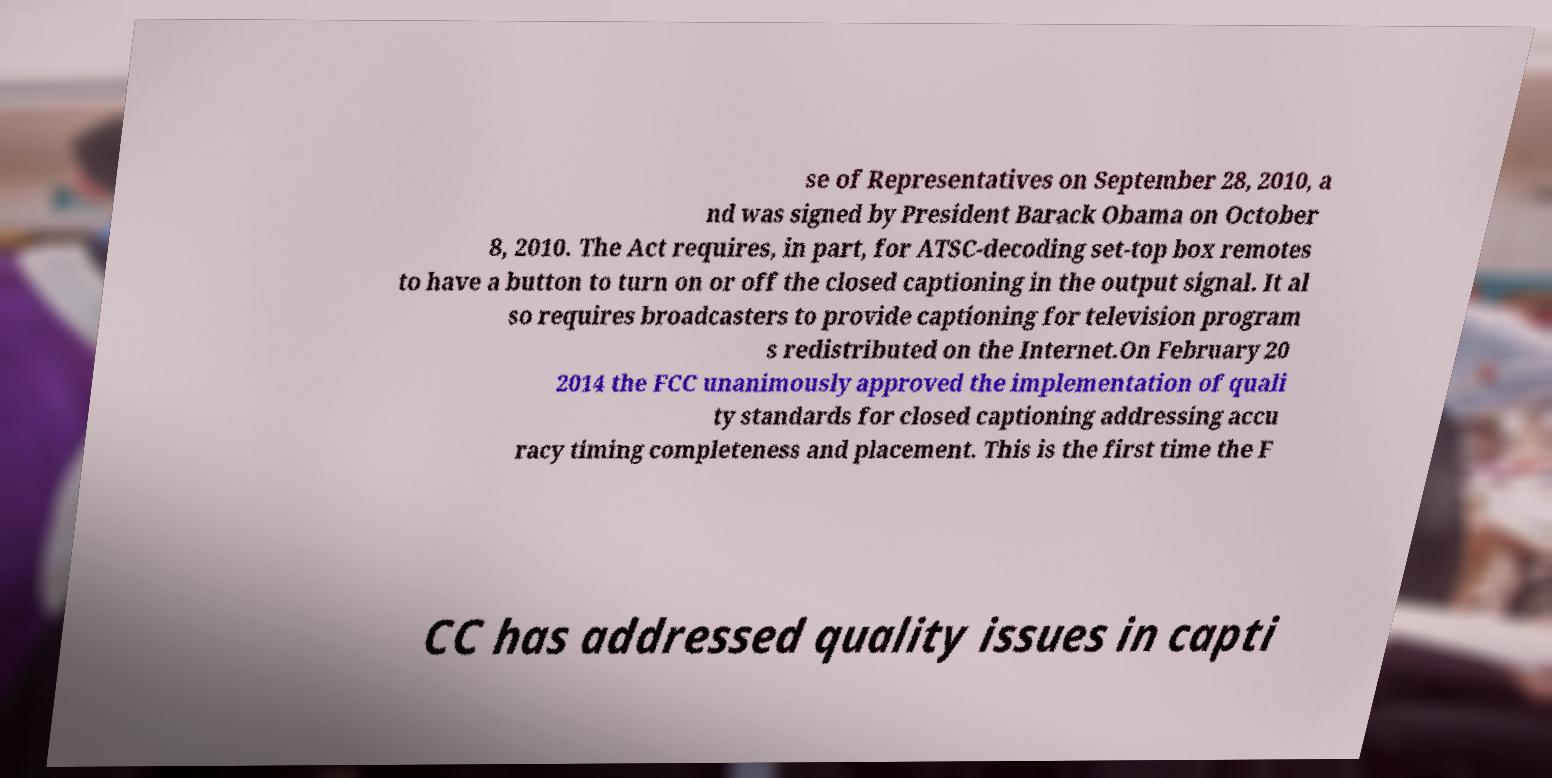What messages or text are displayed in this image? I need them in a readable, typed format. se of Representatives on September 28, 2010, a nd was signed by President Barack Obama on October 8, 2010. The Act requires, in part, for ATSC-decoding set-top box remotes to have a button to turn on or off the closed captioning in the output signal. It al so requires broadcasters to provide captioning for television program s redistributed on the Internet.On February 20 2014 the FCC unanimously approved the implementation of quali ty standards for closed captioning addressing accu racy timing completeness and placement. This is the first time the F CC has addressed quality issues in capti 